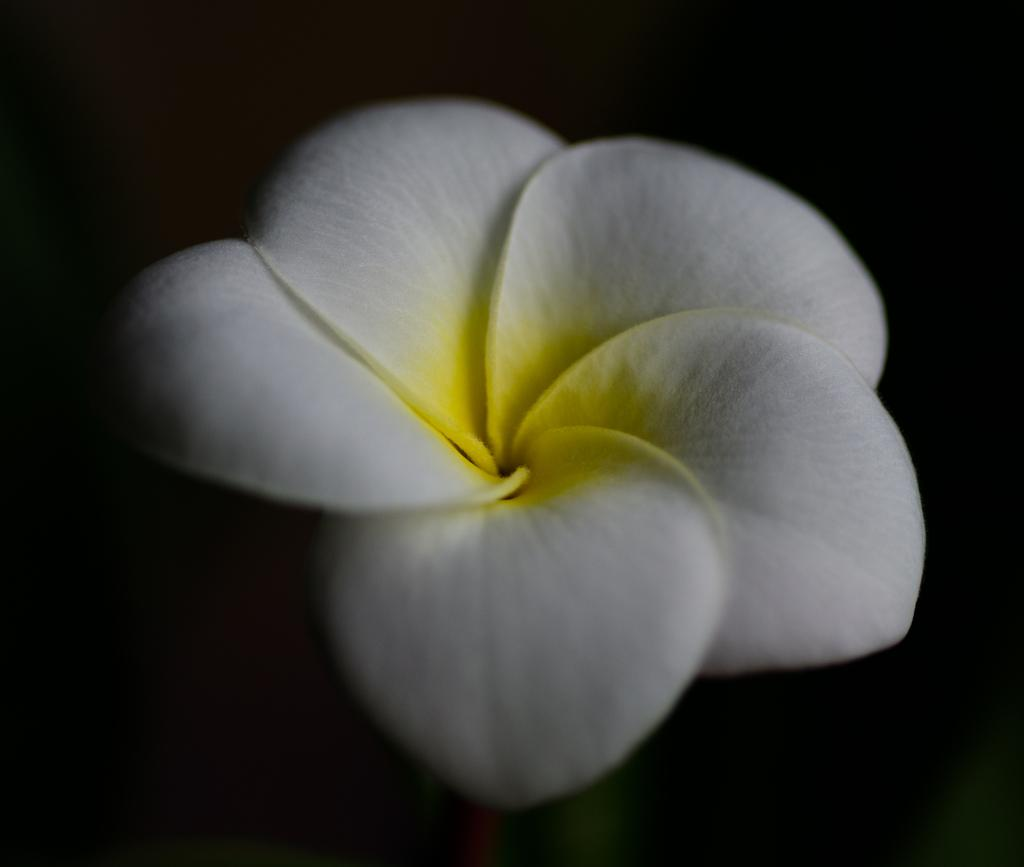What is the focus of the image? The image is zoomed in on a white color flower. Can you describe the flower in the image? The flower is white and is located in the center of the image. What can be observed about the background of the image? The background of the image is very dark. How does the whip crack in the image? There is no whip present in the image; it only features a white color flower. Can you describe the flight pattern of the fly in the image? There is no fly present in the image; it only features a white color flower. 